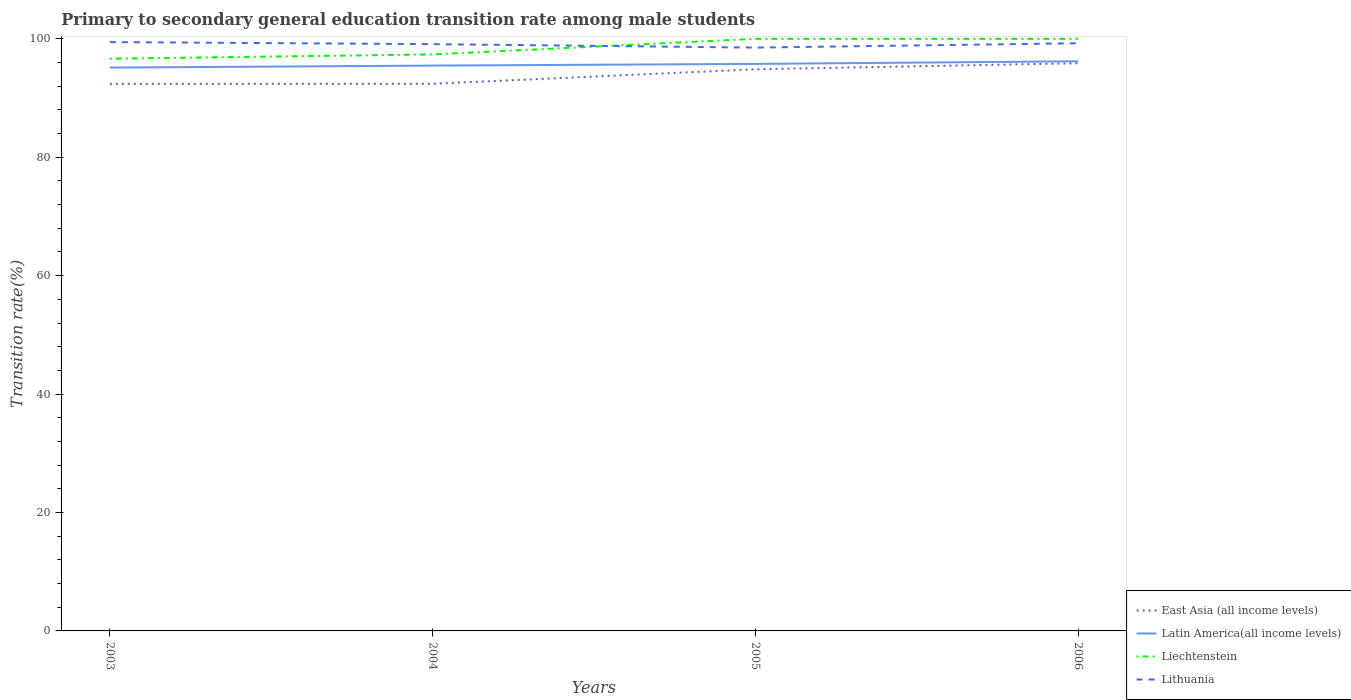How many different coloured lines are there?
Give a very brief answer. 4. Is the number of lines equal to the number of legend labels?
Provide a short and direct response. Yes. Across all years, what is the maximum transition rate in Lithuania?
Keep it short and to the point. 98.52. In which year was the transition rate in Liechtenstein maximum?
Your response must be concise. 2003. What is the total transition rate in East Asia (all income levels) in the graph?
Keep it short and to the point. -1.02. What is the difference between the highest and the second highest transition rate in Liechtenstein?
Your answer should be very brief. 3.36. What is the difference between the highest and the lowest transition rate in Lithuania?
Offer a very short reply. 3. How many lines are there?
Keep it short and to the point. 4. What is the difference between two consecutive major ticks on the Y-axis?
Provide a succinct answer. 20. Are the values on the major ticks of Y-axis written in scientific E-notation?
Offer a terse response. No. Does the graph contain any zero values?
Your answer should be compact. No. Where does the legend appear in the graph?
Keep it short and to the point. Bottom right. How many legend labels are there?
Provide a succinct answer. 4. What is the title of the graph?
Your answer should be very brief. Primary to secondary general education transition rate among male students. Does "Mongolia" appear as one of the legend labels in the graph?
Your answer should be compact. No. What is the label or title of the X-axis?
Provide a short and direct response. Years. What is the label or title of the Y-axis?
Your response must be concise. Transition rate(%). What is the Transition rate(%) in East Asia (all income levels) in 2003?
Offer a terse response. 92.39. What is the Transition rate(%) of Latin America(all income levels) in 2003?
Provide a succinct answer. 95.14. What is the Transition rate(%) in Liechtenstein in 2003?
Provide a short and direct response. 96.64. What is the Transition rate(%) in Lithuania in 2003?
Your answer should be compact. 99.45. What is the Transition rate(%) in East Asia (all income levels) in 2004?
Offer a very short reply. 92.41. What is the Transition rate(%) of Latin America(all income levels) in 2004?
Provide a short and direct response. 95.48. What is the Transition rate(%) of Liechtenstein in 2004?
Your response must be concise. 97.37. What is the Transition rate(%) in Lithuania in 2004?
Make the answer very short. 99.1. What is the Transition rate(%) in East Asia (all income levels) in 2005?
Provide a succinct answer. 94.86. What is the Transition rate(%) of Latin America(all income levels) in 2005?
Your answer should be very brief. 95.76. What is the Transition rate(%) of Lithuania in 2005?
Offer a terse response. 98.52. What is the Transition rate(%) of East Asia (all income levels) in 2006?
Keep it short and to the point. 95.88. What is the Transition rate(%) of Latin America(all income levels) in 2006?
Your answer should be compact. 96.21. What is the Transition rate(%) in Lithuania in 2006?
Your answer should be compact. 99.25. Across all years, what is the maximum Transition rate(%) in East Asia (all income levels)?
Provide a short and direct response. 95.88. Across all years, what is the maximum Transition rate(%) of Latin America(all income levels)?
Offer a terse response. 96.21. Across all years, what is the maximum Transition rate(%) of Lithuania?
Keep it short and to the point. 99.45. Across all years, what is the minimum Transition rate(%) in East Asia (all income levels)?
Offer a very short reply. 92.39. Across all years, what is the minimum Transition rate(%) of Latin America(all income levels)?
Offer a very short reply. 95.14. Across all years, what is the minimum Transition rate(%) of Liechtenstein?
Make the answer very short. 96.64. Across all years, what is the minimum Transition rate(%) in Lithuania?
Your response must be concise. 98.52. What is the total Transition rate(%) of East Asia (all income levels) in the graph?
Offer a terse response. 375.54. What is the total Transition rate(%) of Latin America(all income levels) in the graph?
Provide a short and direct response. 382.59. What is the total Transition rate(%) in Liechtenstein in the graph?
Give a very brief answer. 394.01. What is the total Transition rate(%) of Lithuania in the graph?
Your response must be concise. 396.32. What is the difference between the Transition rate(%) of East Asia (all income levels) in 2003 and that in 2004?
Offer a terse response. -0.01. What is the difference between the Transition rate(%) of Latin America(all income levels) in 2003 and that in 2004?
Offer a terse response. -0.34. What is the difference between the Transition rate(%) of Liechtenstein in 2003 and that in 2004?
Ensure brevity in your answer.  -0.72. What is the difference between the Transition rate(%) of Lithuania in 2003 and that in 2004?
Give a very brief answer. 0.35. What is the difference between the Transition rate(%) in East Asia (all income levels) in 2003 and that in 2005?
Your answer should be compact. -2.47. What is the difference between the Transition rate(%) in Latin America(all income levels) in 2003 and that in 2005?
Ensure brevity in your answer.  -0.62. What is the difference between the Transition rate(%) in Liechtenstein in 2003 and that in 2005?
Keep it short and to the point. -3.36. What is the difference between the Transition rate(%) in Lithuania in 2003 and that in 2005?
Offer a terse response. 0.93. What is the difference between the Transition rate(%) in East Asia (all income levels) in 2003 and that in 2006?
Your answer should be very brief. -3.48. What is the difference between the Transition rate(%) of Latin America(all income levels) in 2003 and that in 2006?
Make the answer very short. -1.07. What is the difference between the Transition rate(%) in Liechtenstein in 2003 and that in 2006?
Your answer should be very brief. -3.36. What is the difference between the Transition rate(%) in Lithuania in 2003 and that in 2006?
Ensure brevity in your answer.  0.2. What is the difference between the Transition rate(%) of East Asia (all income levels) in 2004 and that in 2005?
Ensure brevity in your answer.  -2.45. What is the difference between the Transition rate(%) of Latin America(all income levels) in 2004 and that in 2005?
Keep it short and to the point. -0.28. What is the difference between the Transition rate(%) of Liechtenstein in 2004 and that in 2005?
Your response must be concise. -2.63. What is the difference between the Transition rate(%) in Lithuania in 2004 and that in 2005?
Ensure brevity in your answer.  0.58. What is the difference between the Transition rate(%) of East Asia (all income levels) in 2004 and that in 2006?
Provide a short and direct response. -3.47. What is the difference between the Transition rate(%) of Latin America(all income levels) in 2004 and that in 2006?
Your answer should be very brief. -0.73. What is the difference between the Transition rate(%) of Liechtenstein in 2004 and that in 2006?
Offer a terse response. -2.63. What is the difference between the Transition rate(%) in Lithuania in 2004 and that in 2006?
Your answer should be very brief. -0.15. What is the difference between the Transition rate(%) of East Asia (all income levels) in 2005 and that in 2006?
Provide a succinct answer. -1.02. What is the difference between the Transition rate(%) in Latin America(all income levels) in 2005 and that in 2006?
Your answer should be very brief. -0.44. What is the difference between the Transition rate(%) in Liechtenstein in 2005 and that in 2006?
Offer a very short reply. 0. What is the difference between the Transition rate(%) in Lithuania in 2005 and that in 2006?
Your answer should be compact. -0.73. What is the difference between the Transition rate(%) of East Asia (all income levels) in 2003 and the Transition rate(%) of Latin America(all income levels) in 2004?
Give a very brief answer. -3.09. What is the difference between the Transition rate(%) in East Asia (all income levels) in 2003 and the Transition rate(%) in Liechtenstein in 2004?
Give a very brief answer. -4.97. What is the difference between the Transition rate(%) of East Asia (all income levels) in 2003 and the Transition rate(%) of Lithuania in 2004?
Give a very brief answer. -6.71. What is the difference between the Transition rate(%) in Latin America(all income levels) in 2003 and the Transition rate(%) in Liechtenstein in 2004?
Make the answer very short. -2.23. What is the difference between the Transition rate(%) of Latin America(all income levels) in 2003 and the Transition rate(%) of Lithuania in 2004?
Make the answer very short. -3.96. What is the difference between the Transition rate(%) in Liechtenstein in 2003 and the Transition rate(%) in Lithuania in 2004?
Keep it short and to the point. -2.46. What is the difference between the Transition rate(%) of East Asia (all income levels) in 2003 and the Transition rate(%) of Latin America(all income levels) in 2005?
Make the answer very short. -3.37. What is the difference between the Transition rate(%) in East Asia (all income levels) in 2003 and the Transition rate(%) in Liechtenstein in 2005?
Provide a short and direct response. -7.61. What is the difference between the Transition rate(%) of East Asia (all income levels) in 2003 and the Transition rate(%) of Lithuania in 2005?
Give a very brief answer. -6.13. What is the difference between the Transition rate(%) in Latin America(all income levels) in 2003 and the Transition rate(%) in Liechtenstein in 2005?
Your answer should be very brief. -4.86. What is the difference between the Transition rate(%) in Latin America(all income levels) in 2003 and the Transition rate(%) in Lithuania in 2005?
Your answer should be compact. -3.38. What is the difference between the Transition rate(%) in Liechtenstein in 2003 and the Transition rate(%) in Lithuania in 2005?
Your response must be concise. -1.88. What is the difference between the Transition rate(%) of East Asia (all income levels) in 2003 and the Transition rate(%) of Latin America(all income levels) in 2006?
Your answer should be compact. -3.82. What is the difference between the Transition rate(%) in East Asia (all income levels) in 2003 and the Transition rate(%) in Liechtenstein in 2006?
Offer a terse response. -7.61. What is the difference between the Transition rate(%) in East Asia (all income levels) in 2003 and the Transition rate(%) in Lithuania in 2006?
Ensure brevity in your answer.  -6.86. What is the difference between the Transition rate(%) in Latin America(all income levels) in 2003 and the Transition rate(%) in Liechtenstein in 2006?
Provide a succinct answer. -4.86. What is the difference between the Transition rate(%) of Latin America(all income levels) in 2003 and the Transition rate(%) of Lithuania in 2006?
Make the answer very short. -4.11. What is the difference between the Transition rate(%) of Liechtenstein in 2003 and the Transition rate(%) of Lithuania in 2006?
Your answer should be very brief. -2.61. What is the difference between the Transition rate(%) of East Asia (all income levels) in 2004 and the Transition rate(%) of Latin America(all income levels) in 2005?
Offer a terse response. -3.36. What is the difference between the Transition rate(%) in East Asia (all income levels) in 2004 and the Transition rate(%) in Liechtenstein in 2005?
Provide a short and direct response. -7.59. What is the difference between the Transition rate(%) of East Asia (all income levels) in 2004 and the Transition rate(%) of Lithuania in 2005?
Ensure brevity in your answer.  -6.11. What is the difference between the Transition rate(%) in Latin America(all income levels) in 2004 and the Transition rate(%) in Liechtenstein in 2005?
Keep it short and to the point. -4.52. What is the difference between the Transition rate(%) of Latin America(all income levels) in 2004 and the Transition rate(%) of Lithuania in 2005?
Provide a short and direct response. -3.04. What is the difference between the Transition rate(%) in Liechtenstein in 2004 and the Transition rate(%) in Lithuania in 2005?
Ensure brevity in your answer.  -1.15. What is the difference between the Transition rate(%) in East Asia (all income levels) in 2004 and the Transition rate(%) in Latin America(all income levels) in 2006?
Your answer should be compact. -3.8. What is the difference between the Transition rate(%) in East Asia (all income levels) in 2004 and the Transition rate(%) in Liechtenstein in 2006?
Give a very brief answer. -7.59. What is the difference between the Transition rate(%) of East Asia (all income levels) in 2004 and the Transition rate(%) of Lithuania in 2006?
Your answer should be compact. -6.84. What is the difference between the Transition rate(%) in Latin America(all income levels) in 2004 and the Transition rate(%) in Liechtenstein in 2006?
Keep it short and to the point. -4.52. What is the difference between the Transition rate(%) in Latin America(all income levels) in 2004 and the Transition rate(%) in Lithuania in 2006?
Your response must be concise. -3.77. What is the difference between the Transition rate(%) in Liechtenstein in 2004 and the Transition rate(%) in Lithuania in 2006?
Keep it short and to the point. -1.89. What is the difference between the Transition rate(%) in East Asia (all income levels) in 2005 and the Transition rate(%) in Latin America(all income levels) in 2006?
Your answer should be very brief. -1.35. What is the difference between the Transition rate(%) of East Asia (all income levels) in 2005 and the Transition rate(%) of Liechtenstein in 2006?
Provide a short and direct response. -5.14. What is the difference between the Transition rate(%) of East Asia (all income levels) in 2005 and the Transition rate(%) of Lithuania in 2006?
Your answer should be compact. -4.39. What is the difference between the Transition rate(%) of Latin America(all income levels) in 2005 and the Transition rate(%) of Liechtenstein in 2006?
Provide a succinct answer. -4.24. What is the difference between the Transition rate(%) in Latin America(all income levels) in 2005 and the Transition rate(%) in Lithuania in 2006?
Your response must be concise. -3.49. What is the difference between the Transition rate(%) in Liechtenstein in 2005 and the Transition rate(%) in Lithuania in 2006?
Offer a terse response. 0.75. What is the average Transition rate(%) in East Asia (all income levels) per year?
Give a very brief answer. 93.88. What is the average Transition rate(%) in Latin America(all income levels) per year?
Offer a terse response. 95.65. What is the average Transition rate(%) of Liechtenstein per year?
Your response must be concise. 98.5. What is the average Transition rate(%) of Lithuania per year?
Make the answer very short. 99.08. In the year 2003, what is the difference between the Transition rate(%) in East Asia (all income levels) and Transition rate(%) in Latin America(all income levels)?
Ensure brevity in your answer.  -2.75. In the year 2003, what is the difference between the Transition rate(%) of East Asia (all income levels) and Transition rate(%) of Liechtenstein?
Ensure brevity in your answer.  -4.25. In the year 2003, what is the difference between the Transition rate(%) of East Asia (all income levels) and Transition rate(%) of Lithuania?
Keep it short and to the point. -7.06. In the year 2003, what is the difference between the Transition rate(%) in Latin America(all income levels) and Transition rate(%) in Liechtenstein?
Your answer should be compact. -1.5. In the year 2003, what is the difference between the Transition rate(%) of Latin America(all income levels) and Transition rate(%) of Lithuania?
Your answer should be very brief. -4.31. In the year 2003, what is the difference between the Transition rate(%) in Liechtenstein and Transition rate(%) in Lithuania?
Your answer should be very brief. -2.81. In the year 2004, what is the difference between the Transition rate(%) of East Asia (all income levels) and Transition rate(%) of Latin America(all income levels)?
Your answer should be very brief. -3.07. In the year 2004, what is the difference between the Transition rate(%) in East Asia (all income levels) and Transition rate(%) in Liechtenstein?
Keep it short and to the point. -4.96. In the year 2004, what is the difference between the Transition rate(%) of East Asia (all income levels) and Transition rate(%) of Lithuania?
Offer a terse response. -6.7. In the year 2004, what is the difference between the Transition rate(%) in Latin America(all income levels) and Transition rate(%) in Liechtenstein?
Your answer should be compact. -1.89. In the year 2004, what is the difference between the Transition rate(%) in Latin America(all income levels) and Transition rate(%) in Lithuania?
Provide a short and direct response. -3.62. In the year 2004, what is the difference between the Transition rate(%) of Liechtenstein and Transition rate(%) of Lithuania?
Give a very brief answer. -1.74. In the year 2005, what is the difference between the Transition rate(%) of East Asia (all income levels) and Transition rate(%) of Latin America(all income levels)?
Give a very brief answer. -0.91. In the year 2005, what is the difference between the Transition rate(%) in East Asia (all income levels) and Transition rate(%) in Liechtenstein?
Keep it short and to the point. -5.14. In the year 2005, what is the difference between the Transition rate(%) of East Asia (all income levels) and Transition rate(%) of Lithuania?
Your answer should be very brief. -3.66. In the year 2005, what is the difference between the Transition rate(%) in Latin America(all income levels) and Transition rate(%) in Liechtenstein?
Your response must be concise. -4.24. In the year 2005, what is the difference between the Transition rate(%) in Latin America(all income levels) and Transition rate(%) in Lithuania?
Offer a very short reply. -2.76. In the year 2005, what is the difference between the Transition rate(%) in Liechtenstein and Transition rate(%) in Lithuania?
Give a very brief answer. 1.48. In the year 2006, what is the difference between the Transition rate(%) of East Asia (all income levels) and Transition rate(%) of Latin America(all income levels)?
Provide a short and direct response. -0.33. In the year 2006, what is the difference between the Transition rate(%) of East Asia (all income levels) and Transition rate(%) of Liechtenstein?
Your answer should be very brief. -4.12. In the year 2006, what is the difference between the Transition rate(%) in East Asia (all income levels) and Transition rate(%) in Lithuania?
Make the answer very short. -3.37. In the year 2006, what is the difference between the Transition rate(%) in Latin America(all income levels) and Transition rate(%) in Liechtenstein?
Provide a short and direct response. -3.79. In the year 2006, what is the difference between the Transition rate(%) in Latin America(all income levels) and Transition rate(%) in Lithuania?
Keep it short and to the point. -3.04. In the year 2006, what is the difference between the Transition rate(%) in Liechtenstein and Transition rate(%) in Lithuania?
Ensure brevity in your answer.  0.75. What is the ratio of the Transition rate(%) of East Asia (all income levels) in 2003 to that in 2004?
Give a very brief answer. 1. What is the ratio of the Transition rate(%) of Lithuania in 2003 to that in 2004?
Offer a terse response. 1. What is the ratio of the Transition rate(%) in East Asia (all income levels) in 2003 to that in 2005?
Give a very brief answer. 0.97. What is the ratio of the Transition rate(%) in Latin America(all income levels) in 2003 to that in 2005?
Your answer should be very brief. 0.99. What is the ratio of the Transition rate(%) of Liechtenstein in 2003 to that in 2005?
Provide a short and direct response. 0.97. What is the ratio of the Transition rate(%) in Lithuania in 2003 to that in 2005?
Make the answer very short. 1.01. What is the ratio of the Transition rate(%) of East Asia (all income levels) in 2003 to that in 2006?
Make the answer very short. 0.96. What is the ratio of the Transition rate(%) of Latin America(all income levels) in 2003 to that in 2006?
Ensure brevity in your answer.  0.99. What is the ratio of the Transition rate(%) of Liechtenstein in 2003 to that in 2006?
Provide a short and direct response. 0.97. What is the ratio of the Transition rate(%) in Lithuania in 2003 to that in 2006?
Offer a terse response. 1. What is the ratio of the Transition rate(%) of East Asia (all income levels) in 2004 to that in 2005?
Provide a succinct answer. 0.97. What is the ratio of the Transition rate(%) of Latin America(all income levels) in 2004 to that in 2005?
Your response must be concise. 1. What is the ratio of the Transition rate(%) in Liechtenstein in 2004 to that in 2005?
Provide a succinct answer. 0.97. What is the ratio of the Transition rate(%) in Lithuania in 2004 to that in 2005?
Provide a succinct answer. 1.01. What is the ratio of the Transition rate(%) in East Asia (all income levels) in 2004 to that in 2006?
Ensure brevity in your answer.  0.96. What is the ratio of the Transition rate(%) in Liechtenstein in 2004 to that in 2006?
Provide a short and direct response. 0.97. What is the ratio of the Transition rate(%) of Liechtenstein in 2005 to that in 2006?
Make the answer very short. 1. What is the difference between the highest and the second highest Transition rate(%) in East Asia (all income levels)?
Give a very brief answer. 1.02. What is the difference between the highest and the second highest Transition rate(%) of Latin America(all income levels)?
Your response must be concise. 0.44. What is the difference between the highest and the second highest Transition rate(%) of Lithuania?
Make the answer very short. 0.2. What is the difference between the highest and the lowest Transition rate(%) of East Asia (all income levels)?
Offer a very short reply. 3.48. What is the difference between the highest and the lowest Transition rate(%) in Latin America(all income levels)?
Keep it short and to the point. 1.07. What is the difference between the highest and the lowest Transition rate(%) of Liechtenstein?
Make the answer very short. 3.36. What is the difference between the highest and the lowest Transition rate(%) of Lithuania?
Keep it short and to the point. 0.93. 